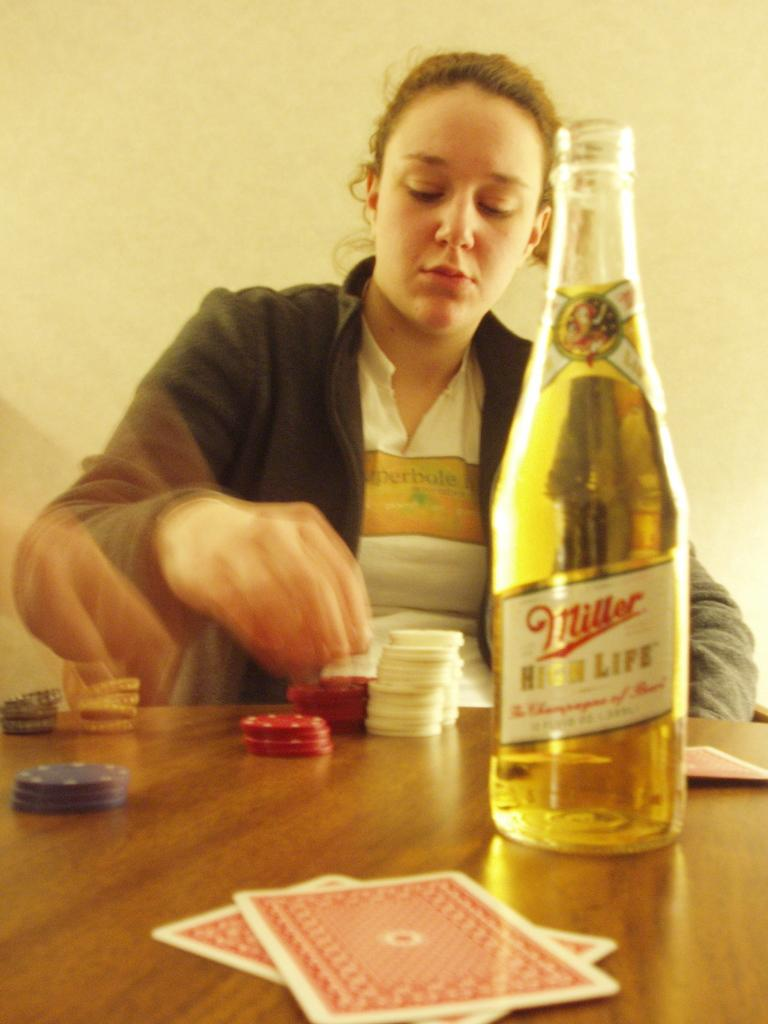<image>
Describe the image concisely. a woman playing with poker chips behind a bottle of miller high life 